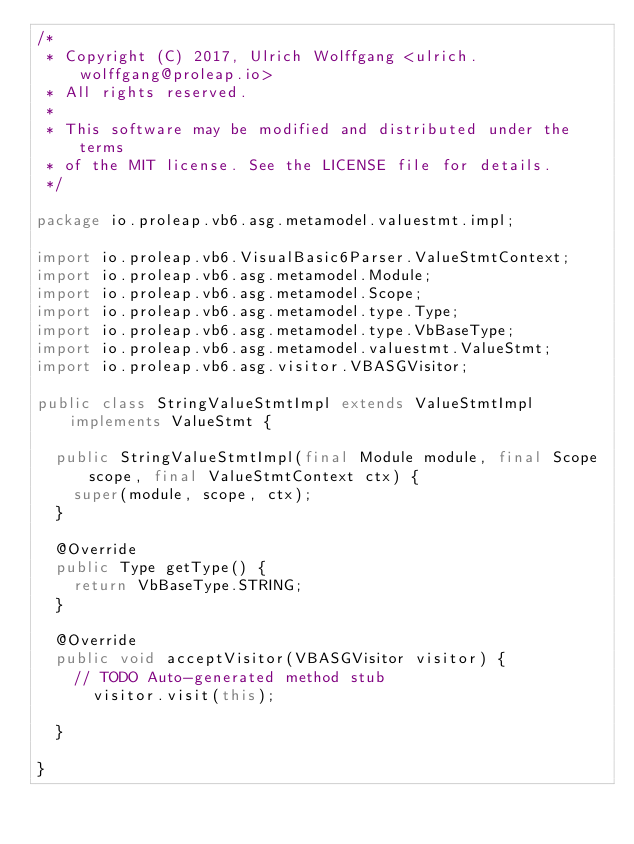<code> <loc_0><loc_0><loc_500><loc_500><_Java_>/*
 * Copyright (C) 2017, Ulrich Wolffgang <ulrich.wolffgang@proleap.io>
 * All rights reserved.
 *
 * This software may be modified and distributed under the terms
 * of the MIT license. See the LICENSE file for details.
 */

package io.proleap.vb6.asg.metamodel.valuestmt.impl;

import io.proleap.vb6.VisualBasic6Parser.ValueStmtContext;
import io.proleap.vb6.asg.metamodel.Module;
import io.proleap.vb6.asg.metamodel.Scope;
import io.proleap.vb6.asg.metamodel.type.Type;
import io.proleap.vb6.asg.metamodel.type.VbBaseType;
import io.proleap.vb6.asg.metamodel.valuestmt.ValueStmt;
import io.proleap.vb6.asg.visitor.VBASGVisitor;

public class StringValueStmtImpl extends ValueStmtImpl implements ValueStmt {

	public StringValueStmtImpl(final Module module, final Scope scope, final ValueStmtContext ctx) {
		super(module, scope, ctx);
	}

	@Override
	public Type getType() {
		return VbBaseType.STRING;
	}

	@Override
	public void acceptVisitor(VBASGVisitor visitor) {
		// TODO Auto-generated method stub
			visitor.visit(this);
		
	}

}
</code> 